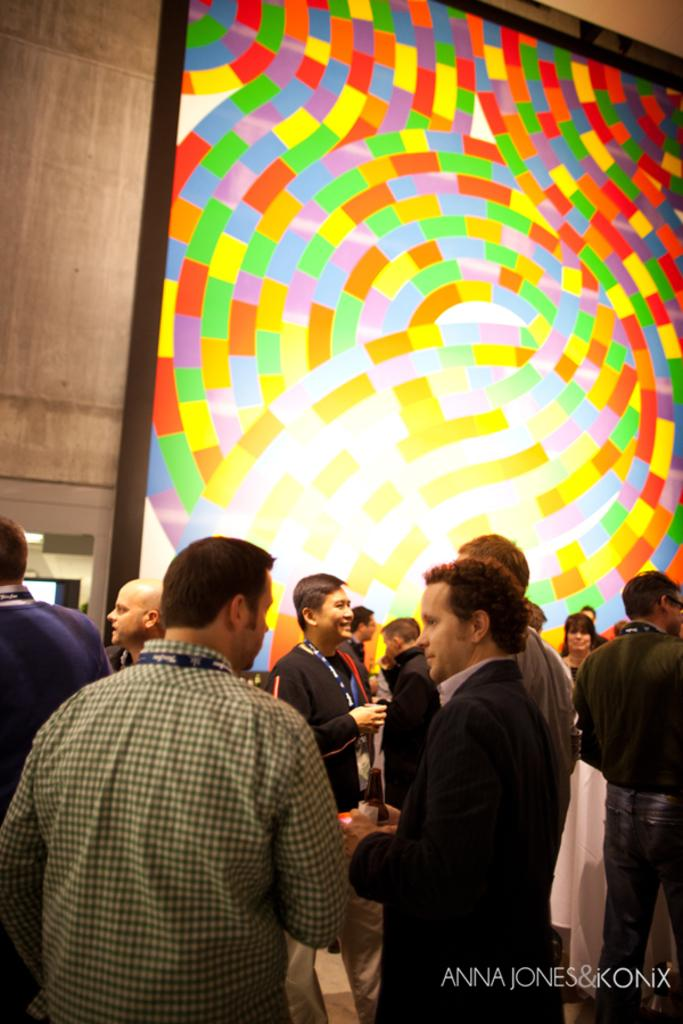What is the main subject of the image? The main subject of the image is a group of people. What are the people in the image doing? The people are standing. What can be seen in the background of the image? There is a colorful poster on the wall in the background. Is there any text visible in the image? Yes, there is some text in the bottom right corner of the image. How many mittens are being worn by the people in the image? There are no mittens visible in the image; the people are not wearing any. 